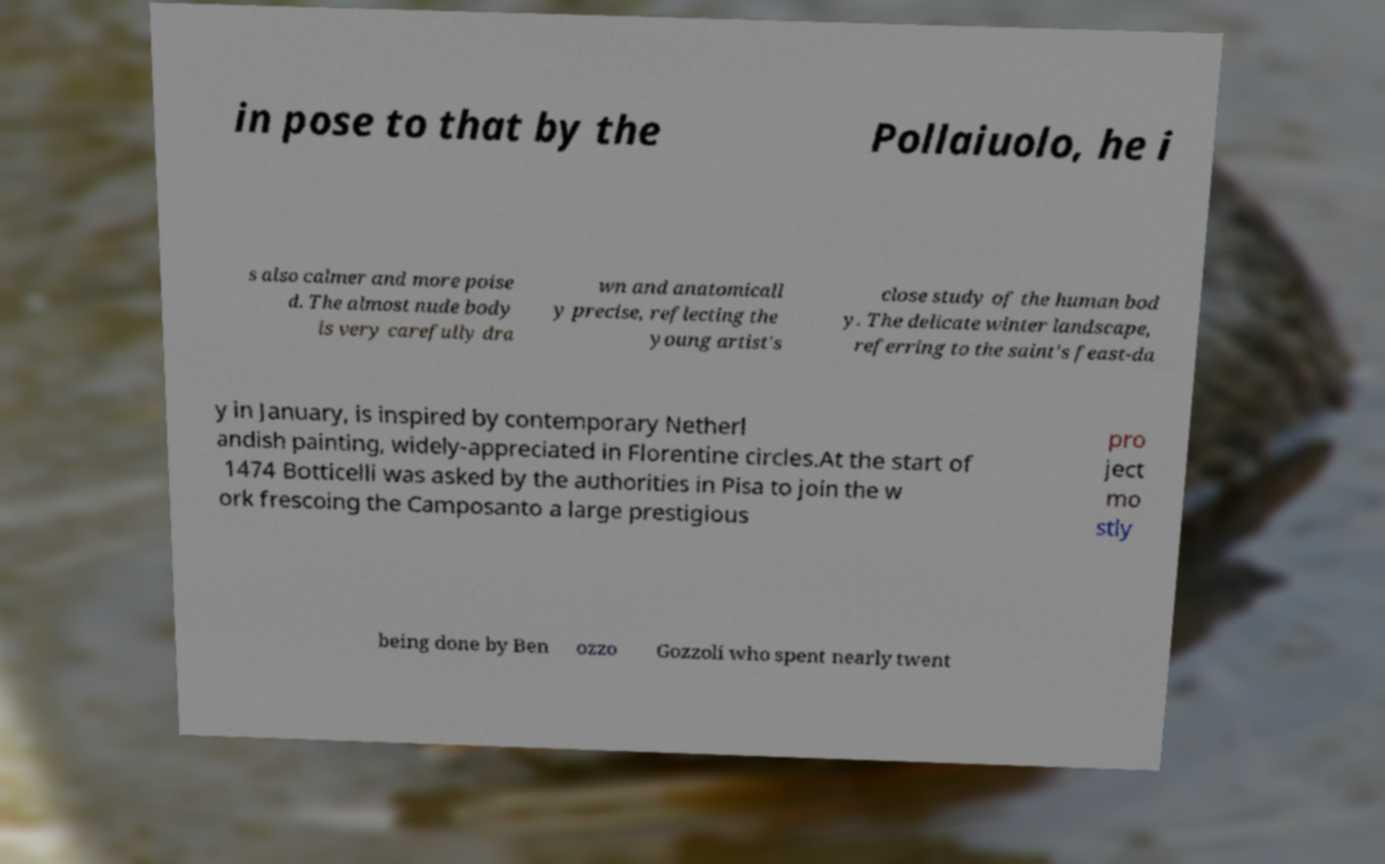Can you accurately transcribe the text from the provided image for me? in pose to that by the Pollaiuolo, he i s also calmer and more poise d. The almost nude body is very carefully dra wn and anatomicall y precise, reflecting the young artist's close study of the human bod y. The delicate winter landscape, referring to the saint's feast-da y in January, is inspired by contemporary Netherl andish painting, widely-appreciated in Florentine circles.At the start of 1474 Botticelli was asked by the authorities in Pisa to join the w ork frescoing the Camposanto a large prestigious pro ject mo stly being done by Ben ozzo Gozzoli who spent nearly twent 